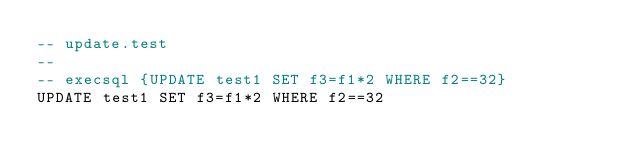<code> <loc_0><loc_0><loc_500><loc_500><_SQL_>-- update.test
-- 
-- execsql {UPDATE test1 SET f3=f1*2 WHERE f2==32}
UPDATE test1 SET f3=f1*2 WHERE f2==32</code> 